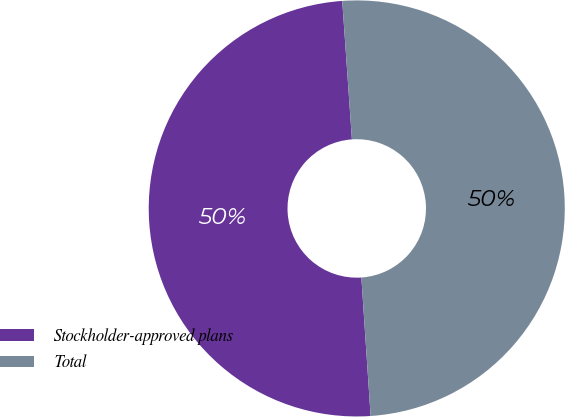Convert chart to OTSL. <chart><loc_0><loc_0><loc_500><loc_500><pie_chart><fcel>Stockholder-approved plans<fcel>Total<nl><fcel>49.95%<fcel>50.05%<nl></chart> 